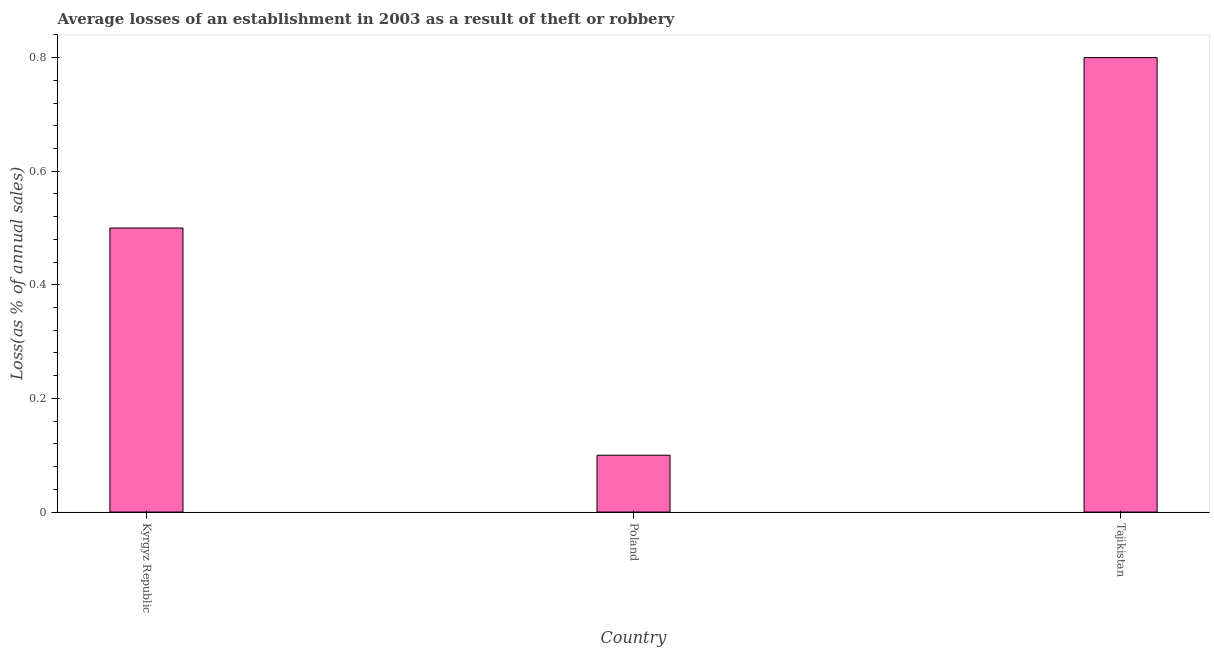Does the graph contain grids?
Provide a short and direct response. No. What is the title of the graph?
Make the answer very short. Average losses of an establishment in 2003 as a result of theft or robbery. What is the label or title of the X-axis?
Keep it short and to the point. Country. What is the label or title of the Y-axis?
Make the answer very short. Loss(as % of annual sales). Across all countries, what is the maximum losses due to theft?
Make the answer very short. 0.8. In which country was the losses due to theft maximum?
Offer a very short reply. Tajikistan. In which country was the losses due to theft minimum?
Your answer should be very brief. Poland. What is the sum of the losses due to theft?
Provide a succinct answer. 1.4. What is the average losses due to theft per country?
Give a very brief answer. 0.47. In how many countries, is the losses due to theft greater than 0.4 %?
Ensure brevity in your answer.  2. What is the ratio of the losses due to theft in Kyrgyz Republic to that in Tajikistan?
Offer a very short reply. 0.62. Is the losses due to theft in Kyrgyz Republic less than that in Tajikistan?
Your answer should be very brief. Yes. What is the difference between the highest and the second highest losses due to theft?
Provide a short and direct response. 0.3. In how many countries, is the losses due to theft greater than the average losses due to theft taken over all countries?
Offer a very short reply. 2. Are all the bars in the graph horizontal?
Offer a terse response. No. How many countries are there in the graph?
Provide a short and direct response. 3. What is the difference between two consecutive major ticks on the Y-axis?
Provide a short and direct response. 0.2. What is the Loss(as % of annual sales) in Kyrgyz Republic?
Give a very brief answer. 0.5. What is the Loss(as % of annual sales) in Poland?
Offer a very short reply. 0.1. What is the difference between the Loss(as % of annual sales) in Kyrgyz Republic and Poland?
Provide a succinct answer. 0.4. What is the ratio of the Loss(as % of annual sales) in Kyrgyz Republic to that in Poland?
Make the answer very short. 5. What is the ratio of the Loss(as % of annual sales) in Poland to that in Tajikistan?
Make the answer very short. 0.12. 